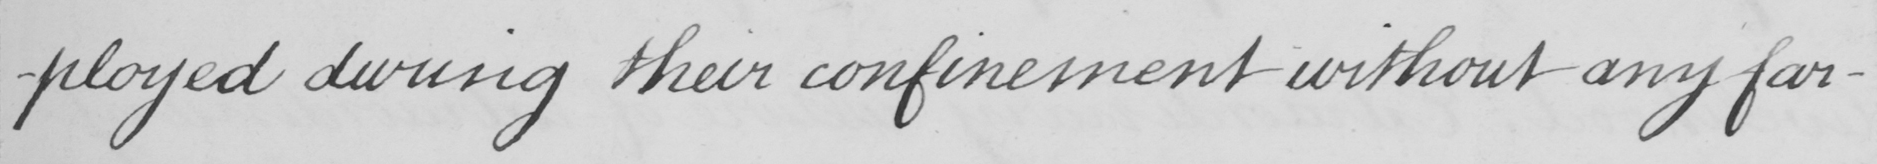Please provide the text content of this handwritten line. -ployed during their confinement without any far- 